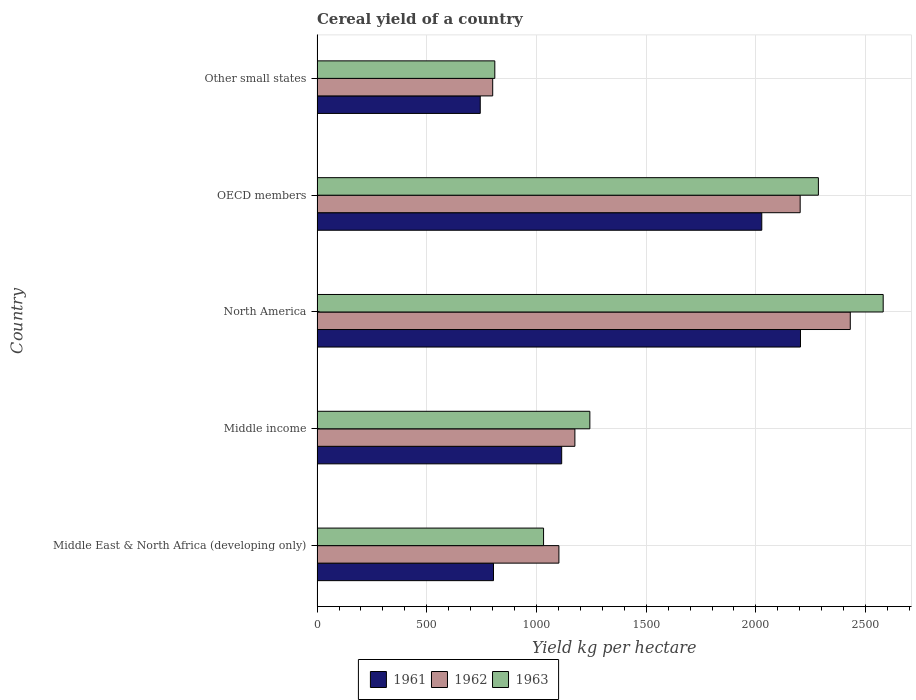How many different coloured bars are there?
Your answer should be compact. 3. How many groups of bars are there?
Keep it short and to the point. 5. How many bars are there on the 1st tick from the top?
Your response must be concise. 3. How many bars are there on the 4th tick from the bottom?
Offer a very short reply. 3. What is the label of the 1st group of bars from the top?
Your response must be concise. Other small states. What is the total cereal yield in 1962 in North America?
Your answer should be very brief. 2430.22. Across all countries, what is the maximum total cereal yield in 1962?
Provide a short and direct response. 2430.22. Across all countries, what is the minimum total cereal yield in 1961?
Keep it short and to the point. 743.8. In which country was the total cereal yield in 1963 minimum?
Make the answer very short. Other small states. What is the total total cereal yield in 1962 in the graph?
Your answer should be compact. 7710.01. What is the difference between the total cereal yield in 1963 in Middle income and that in Other small states?
Ensure brevity in your answer.  433.18. What is the difference between the total cereal yield in 1962 in Other small states and the total cereal yield in 1963 in Middle East & North Africa (developing only)?
Make the answer very short. -231.78. What is the average total cereal yield in 1962 per country?
Your response must be concise. 1542. What is the difference between the total cereal yield in 1961 and total cereal yield in 1962 in Middle East & North Africa (developing only)?
Ensure brevity in your answer.  -298.12. What is the ratio of the total cereal yield in 1961 in Middle income to that in OECD members?
Provide a short and direct response. 0.55. Is the total cereal yield in 1961 in Middle East & North Africa (developing only) less than that in OECD members?
Offer a very short reply. Yes. What is the difference between the highest and the second highest total cereal yield in 1962?
Keep it short and to the point. 228.34. What is the difference between the highest and the lowest total cereal yield in 1963?
Give a very brief answer. 1770.06. Is the sum of the total cereal yield in 1962 in Middle East & North Africa (developing only) and Middle income greater than the maximum total cereal yield in 1963 across all countries?
Provide a short and direct response. No. What does the 3rd bar from the top in Other small states represents?
Offer a very short reply. 1961. Is it the case that in every country, the sum of the total cereal yield in 1962 and total cereal yield in 1963 is greater than the total cereal yield in 1961?
Provide a short and direct response. Yes. How many countries are there in the graph?
Give a very brief answer. 5. Are the values on the major ticks of X-axis written in scientific E-notation?
Your answer should be very brief. No. Does the graph contain any zero values?
Offer a terse response. No. Where does the legend appear in the graph?
Provide a succinct answer. Bottom center. How many legend labels are there?
Offer a very short reply. 3. How are the legend labels stacked?
Keep it short and to the point. Horizontal. What is the title of the graph?
Make the answer very short. Cereal yield of a country. Does "1985" appear as one of the legend labels in the graph?
Provide a short and direct response. No. What is the label or title of the X-axis?
Your answer should be very brief. Yield kg per hectare. What is the label or title of the Y-axis?
Provide a succinct answer. Country. What is the Yield kg per hectare of 1961 in Middle East & North Africa (developing only)?
Ensure brevity in your answer.  804.16. What is the Yield kg per hectare in 1962 in Middle East & North Africa (developing only)?
Make the answer very short. 1102.28. What is the Yield kg per hectare in 1963 in Middle East & North Africa (developing only)?
Your answer should be very brief. 1032.31. What is the Yield kg per hectare in 1961 in Middle income?
Keep it short and to the point. 1114.95. What is the Yield kg per hectare of 1962 in Middle income?
Your answer should be compact. 1175.1. What is the Yield kg per hectare of 1963 in Middle income?
Provide a succinct answer. 1243.31. What is the Yield kg per hectare in 1961 in North America?
Provide a succinct answer. 2203.29. What is the Yield kg per hectare in 1962 in North America?
Ensure brevity in your answer.  2430.22. What is the Yield kg per hectare of 1963 in North America?
Your answer should be compact. 2580.19. What is the Yield kg per hectare in 1961 in OECD members?
Your response must be concise. 2026.89. What is the Yield kg per hectare of 1962 in OECD members?
Give a very brief answer. 2201.88. What is the Yield kg per hectare in 1963 in OECD members?
Offer a terse response. 2284.91. What is the Yield kg per hectare in 1961 in Other small states?
Give a very brief answer. 743.8. What is the Yield kg per hectare of 1962 in Other small states?
Your answer should be very brief. 800.53. What is the Yield kg per hectare of 1963 in Other small states?
Provide a succinct answer. 810.13. Across all countries, what is the maximum Yield kg per hectare of 1961?
Your response must be concise. 2203.29. Across all countries, what is the maximum Yield kg per hectare of 1962?
Make the answer very short. 2430.22. Across all countries, what is the maximum Yield kg per hectare of 1963?
Make the answer very short. 2580.19. Across all countries, what is the minimum Yield kg per hectare in 1961?
Your answer should be compact. 743.8. Across all countries, what is the minimum Yield kg per hectare in 1962?
Your response must be concise. 800.53. Across all countries, what is the minimum Yield kg per hectare in 1963?
Give a very brief answer. 810.13. What is the total Yield kg per hectare of 1961 in the graph?
Your response must be concise. 6893.09. What is the total Yield kg per hectare of 1962 in the graph?
Give a very brief answer. 7710.01. What is the total Yield kg per hectare of 1963 in the graph?
Make the answer very short. 7950.86. What is the difference between the Yield kg per hectare in 1961 in Middle East & North Africa (developing only) and that in Middle income?
Make the answer very short. -310.79. What is the difference between the Yield kg per hectare of 1962 in Middle East & North Africa (developing only) and that in Middle income?
Your answer should be very brief. -72.82. What is the difference between the Yield kg per hectare of 1963 in Middle East & North Africa (developing only) and that in Middle income?
Ensure brevity in your answer.  -211. What is the difference between the Yield kg per hectare of 1961 in Middle East & North Africa (developing only) and that in North America?
Offer a very short reply. -1399.14. What is the difference between the Yield kg per hectare of 1962 in Middle East & North Africa (developing only) and that in North America?
Offer a terse response. -1327.94. What is the difference between the Yield kg per hectare of 1963 in Middle East & North Africa (developing only) and that in North America?
Provide a succinct answer. -1547.89. What is the difference between the Yield kg per hectare in 1961 in Middle East & North Africa (developing only) and that in OECD members?
Your answer should be very brief. -1222.73. What is the difference between the Yield kg per hectare in 1962 in Middle East & North Africa (developing only) and that in OECD members?
Your response must be concise. -1099.6. What is the difference between the Yield kg per hectare in 1963 in Middle East & North Africa (developing only) and that in OECD members?
Provide a short and direct response. -1252.61. What is the difference between the Yield kg per hectare in 1961 in Middle East & North Africa (developing only) and that in Other small states?
Offer a very short reply. 60.36. What is the difference between the Yield kg per hectare in 1962 in Middle East & North Africa (developing only) and that in Other small states?
Provide a succinct answer. 301.75. What is the difference between the Yield kg per hectare of 1963 in Middle East & North Africa (developing only) and that in Other small states?
Offer a very short reply. 222.18. What is the difference between the Yield kg per hectare of 1961 in Middle income and that in North America?
Provide a succinct answer. -1088.35. What is the difference between the Yield kg per hectare in 1962 in Middle income and that in North America?
Your response must be concise. -1255.12. What is the difference between the Yield kg per hectare of 1963 in Middle income and that in North America?
Make the answer very short. -1336.88. What is the difference between the Yield kg per hectare in 1961 in Middle income and that in OECD members?
Keep it short and to the point. -911.94. What is the difference between the Yield kg per hectare of 1962 in Middle income and that in OECD members?
Give a very brief answer. -1026.78. What is the difference between the Yield kg per hectare of 1963 in Middle income and that in OECD members?
Give a very brief answer. -1041.6. What is the difference between the Yield kg per hectare in 1961 in Middle income and that in Other small states?
Offer a terse response. 371.14. What is the difference between the Yield kg per hectare in 1962 in Middle income and that in Other small states?
Your response must be concise. 374.57. What is the difference between the Yield kg per hectare of 1963 in Middle income and that in Other small states?
Give a very brief answer. 433.18. What is the difference between the Yield kg per hectare in 1961 in North America and that in OECD members?
Your answer should be compact. 176.41. What is the difference between the Yield kg per hectare in 1962 in North America and that in OECD members?
Offer a terse response. 228.34. What is the difference between the Yield kg per hectare of 1963 in North America and that in OECD members?
Provide a succinct answer. 295.28. What is the difference between the Yield kg per hectare of 1961 in North America and that in Other small states?
Provide a succinct answer. 1459.49. What is the difference between the Yield kg per hectare in 1962 in North America and that in Other small states?
Provide a succinct answer. 1629.69. What is the difference between the Yield kg per hectare in 1963 in North America and that in Other small states?
Ensure brevity in your answer.  1770.06. What is the difference between the Yield kg per hectare in 1961 in OECD members and that in Other small states?
Provide a succinct answer. 1283.09. What is the difference between the Yield kg per hectare of 1962 in OECD members and that in Other small states?
Offer a terse response. 1401.35. What is the difference between the Yield kg per hectare in 1963 in OECD members and that in Other small states?
Keep it short and to the point. 1474.78. What is the difference between the Yield kg per hectare in 1961 in Middle East & North Africa (developing only) and the Yield kg per hectare in 1962 in Middle income?
Provide a short and direct response. -370.94. What is the difference between the Yield kg per hectare of 1961 in Middle East & North Africa (developing only) and the Yield kg per hectare of 1963 in Middle income?
Your answer should be compact. -439.15. What is the difference between the Yield kg per hectare of 1962 in Middle East & North Africa (developing only) and the Yield kg per hectare of 1963 in Middle income?
Provide a succinct answer. -141.03. What is the difference between the Yield kg per hectare in 1961 in Middle East & North Africa (developing only) and the Yield kg per hectare in 1962 in North America?
Keep it short and to the point. -1626.06. What is the difference between the Yield kg per hectare in 1961 in Middle East & North Africa (developing only) and the Yield kg per hectare in 1963 in North America?
Your answer should be compact. -1776.04. What is the difference between the Yield kg per hectare in 1962 in Middle East & North Africa (developing only) and the Yield kg per hectare in 1963 in North America?
Your answer should be very brief. -1477.91. What is the difference between the Yield kg per hectare in 1961 in Middle East & North Africa (developing only) and the Yield kg per hectare in 1962 in OECD members?
Give a very brief answer. -1397.72. What is the difference between the Yield kg per hectare of 1961 in Middle East & North Africa (developing only) and the Yield kg per hectare of 1963 in OECD members?
Ensure brevity in your answer.  -1480.76. What is the difference between the Yield kg per hectare in 1962 in Middle East & North Africa (developing only) and the Yield kg per hectare in 1963 in OECD members?
Ensure brevity in your answer.  -1182.63. What is the difference between the Yield kg per hectare in 1961 in Middle East & North Africa (developing only) and the Yield kg per hectare in 1962 in Other small states?
Offer a very short reply. 3.63. What is the difference between the Yield kg per hectare in 1961 in Middle East & North Africa (developing only) and the Yield kg per hectare in 1963 in Other small states?
Your answer should be very brief. -5.97. What is the difference between the Yield kg per hectare in 1962 in Middle East & North Africa (developing only) and the Yield kg per hectare in 1963 in Other small states?
Keep it short and to the point. 292.15. What is the difference between the Yield kg per hectare of 1961 in Middle income and the Yield kg per hectare of 1962 in North America?
Keep it short and to the point. -1315.27. What is the difference between the Yield kg per hectare in 1961 in Middle income and the Yield kg per hectare in 1963 in North America?
Offer a terse response. -1465.25. What is the difference between the Yield kg per hectare of 1962 in Middle income and the Yield kg per hectare of 1963 in North America?
Your answer should be very brief. -1405.09. What is the difference between the Yield kg per hectare of 1961 in Middle income and the Yield kg per hectare of 1962 in OECD members?
Your answer should be compact. -1086.93. What is the difference between the Yield kg per hectare in 1961 in Middle income and the Yield kg per hectare in 1963 in OECD members?
Your answer should be very brief. -1169.97. What is the difference between the Yield kg per hectare in 1962 in Middle income and the Yield kg per hectare in 1963 in OECD members?
Provide a short and direct response. -1109.81. What is the difference between the Yield kg per hectare of 1961 in Middle income and the Yield kg per hectare of 1962 in Other small states?
Your response must be concise. 314.41. What is the difference between the Yield kg per hectare in 1961 in Middle income and the Yield kg per hectare in 1963 in Other small states?
Your answer should be compact. 304.82. What is the difference between the Yield kg per hectare in 1962 in Middle income and the Yield kg per hectare in 1963 in Other small states?
Give a very brief answer. 364.97. What is the difference between the Yield kg per hectare of 1961 in North America and the Yield kg per hectare of 1962 in OECD members?
Provide a succinct answer. 1.41. What is the difference between the Yield kg per hectare in 1961 in North America and the Yield kg per hectare in 1963 in OECD members?
Your response must be concise. -81.62. What is the difference between the Yield kg per hectare in 1962 in North America and the Yield kg per hectare in 1963 in OECD members?
Your answer should be very brief. 145.3. What is the difference between the Yield kg per hectare of 1961 in North America and the Yield kg per hectare of 1962 in Other small states?
Your response must be concise. 1402.76. What is the difference between the Yield kg per hectare of 1961 in North America and the Yield kg per hectare of 1963 in Other small states?
Give a very brief answer. 1393.16. What is the difference between the Yield kg per hectare of 1962 in North America and the Yield kg per hectare of 1963 in Other small states?
Offer a very short reply. 1620.09. What is the difference between the Yield kg per hectare of 1961 in OECD members and the Yield kg per hectare of 1962 in Other small states?
Provide a succinct answer. 1226.36. What is the difference between the Yield kg per hectare in 1961 in OECD members and the Yield kg per hectare in 1963 in Other small states?
Ensure brevity in your answer.  1216.76. What is the difference between the Yield kg per hectare of 1962 in OECD members and the Yield kg per hectare of 1963 in Other small states?
Offer a terse response. 1391.75. What is the average Yield kg per hectare of 1961 per country?
Ensure brevity in your answer.  1378.62. What is the average Yield kg per hectare of 1962 per country?
Offer a terse response. 1542. What is the average Yield kg per hectare of 1963 per country?
Offer a very short reply. 1590.17. What is the difference between the Yield kg per hectare of 1961 and Yield kg per hectare of 1962 in Middle East & North Africa (developing only)?
Give a very brief answer. -298.12. What is the difference between the Yield kg per hectare of 1961 and Yield kg per hectare of 1963 in Middle East & North Africa (developing only)?
Make the answer very short. -228.15. What is the difference between the Yield kg per hectare in 1962 and Yield kg per hectare in 1963 in Middle East & North Africa (developing only)?
Your answer should be compact. 69.97. What is the difference between the Yield kg per hectare in 1961 and Yield kg per hectare in 1962 in Middle income?
Keep it short and to the point. -60.15. What is the difference between the Yield kg per hectare of 1961 and Yield kg per hectare of 1963 in Middle income?
Your answer should be compact. -128.37. What is the difference between the Yield kg per hectare in 1962 and Yield kg per hectare in 1963 in Middle income?
Keep it short and to the point. -68.21. What is the difference between the Yield kg per hectare in 1961 and Yield kg per hectare in 1962 in North America?
Ensure brevity in your answer.  -226.92. What is the difference between the Yield kg per hectare in 1961 and Yield kg per hectare in 1963 in North America?
Your answer should be very brief. -376.9. What is the difference between the Yield kg per hectare of 1962 and Yield kg per hectare of 1963 in North America?
Your response must be concise. -149.98. What is the difference between the Yield kg per hectare of 1961 and Yield kg per hectare of 1962 in OECD members?
Offer a terse response. -174.99. What is the difference between the Yield kg per hectare in 1961 and Yield kg per hectare in 1963 in OECD members?
Make the answer very short. -258.03. What is the difference between the Yield kg per hectare of 1962 and Yield kg per hectare of 1963 in OECD members?
Make the answer very short. -83.03. What is the difference between the Yield kg per hectare of 1961 and Yield kg per hectare of 1962 in Other small states?
Ensure brevity in your answer.  -56.73. What is the difference between the Yield kg per hectare in 1961 and Yield kg per hectare in 1963 in Other small states?
Keep it short and to the point. -66.33. What is the difference between the Yield kg per hectare in 1962 and Yield kg per hectare in 1963 in Other small states?
Make the answer very short. -9.6. What is the ratio of the Yield kg per hectare of 1961 in Middle East & North Africa (developing only) to that in Middle income?
Ensure brevity in your answer.  0.72. What is the ratio of the Yield kg per hectare of 1962 in Middle East & North Africa (developing only) to that in Middle income?
Your answer should be very brief. 0.94. What is the ratio of the Yield kg per hectare of 1963 in Middle East & North Africa (developing only) to that in Middle income?
Provide a succinct answer. 0.83. What is the ratio of the Yield kg per hectare in 1961 in Middle East & North Africa (developing only) to that in North America?
Provide a short and direct response. 0.36. What is the ratio of the Yield kg per hectare in 1962 in Middle East & North Africa (developing only) to that in North America?
Your answer should be compact. 0.45. What is the ratio of the Yield kg per hectare of 1963 in Middle East & North Africa (developing only) to that in North America?
Your response must be concise. 0.4. What is the ratio of the Yield kg per hectare of 1961 in Middle East & North Africa (developing only) to that in OECD members?
Give a very brief answer. 0.4. What is the ratio of the Yield kg per hectare in 1962 in Middle East & North Africa (developing only) to that in OECD members?
Your answer should be very brief. 0.5. What is the ratio of the Yield kg per hectare of 1963 in Middle East & North Africa (developing only) to that in OECD members?
Provide a succinct answer. 0.45. What is the ratio of the Yield kg per hectare in 1961 in Middle East & North Africa (developing only) to that in Other small states?
Keep it short and to the point. 1.08. What is the ratio of the Yield kg per hectare of 1962 in Middle East & North Africa (developing only) to that in Other small states?
Keep it short and to the point. 1.38. What is the ratio of the Yield kg per hectare in 1963 in Middle East & North Africa (developing only) to that in Other small states?
Offer a terse response. 1.27. What is the ratio of the Yield kg per hectare of 1961 in Middle income to that in North America?
Offer a terse response. 0.51. What is the ratio of the Yield kg per hectare of 1962 in Middle income to that in North America?
Your response must be concise. 0.48. What is the ratio of the Yield kg per hectare of 1963 in Middle income to that in North America?
Offer a terse response. 0.48. What is the ratio of the Yield kg per hectare of 1961 in Middle income to that in OECD members?
Make the answer very short. 0.55. What is the ratio of the Yield kg per hectare in 1962 in Middle income to that in OECD members?
Provide a short and direct response. 0.53. What is the ratio of the Yield kg per hectare of 1963 in Middle income to that in OECD members?
Ensure brevity in your answer.  0.54. What is the ratio of the Yield kg per hectare of 1961 in Middle income to that in Other small states?
Make the answer very short. 1.5. What is the ratio of the Yield kg per hectare of 1962 in Middle income to that in Other small states?
Your response must be concise. 1.47. What is the ratio of the Yield kg per hectare of 1963 in Middle income to that in Other small states?
Offer a very short reply. 1.53. What is the ratio of the Yield kg per hectare of 1961 in North America to that in OECD members?
Give a very brief answer. 1.09. What is the ratio of the Yield kg per hectare in 1962 in North America to that in OECD members?
Offer a very short reply. 1.1. What is the ratio of the Yield kg per hectare of 1963 in North America to that in OECD members?
Provide a short and direct response. 1.13. What is the ratio of the Yield kg per hectare of 1961 in North America to that in Other small states?
Provide a succinct answer. 2.96. What is the ratio of the Yield kg per hectare of 1962 in North America to that in Other small states?
Offer a very short reply. 3.04. What is the ratio of the Yield kg per hectare in 1963 in North America to that in Other small states?
Your answer should be compact. 3.18. What is the ratio of the Yield kg per hectare in 1961 in OECD members to that in Other small states?
Give a very brief answer. 2.73. What is the ratio of the Yield kg per hectare of 1962 in OECD members to that in Other small states?
Your answer should be compact. 2.75. What is the ratio of the Yield kg per hectare in 1963 in OECD members to that in Other small states?
Ensure brevity in your answer.  2.82. What is the difference between the highest and the second highest Yield kg per hectare in 1961?
Your response must be concise. 176.41. What is the difference between the highest and the second highest Yield kg per hectare of 1962?
Make the answer very short. 228.34. What is the difference between the highest and the second highest Yield kg per hectare of 1963?
Ensure brevity in your answer.  295.28. What is the difference between the highest and the lowest Yield kg per hectare in 1961?
Your answer should be compact. 1459.49. What is the difference between the highest and the lowest Yield kg per hectare in 1962?
Your answer should be very brief. 1629.69. What is the difference between the highest and the lowest Yield kg per hectare in 1963?
Your answer should be very brief. 1770.06. 